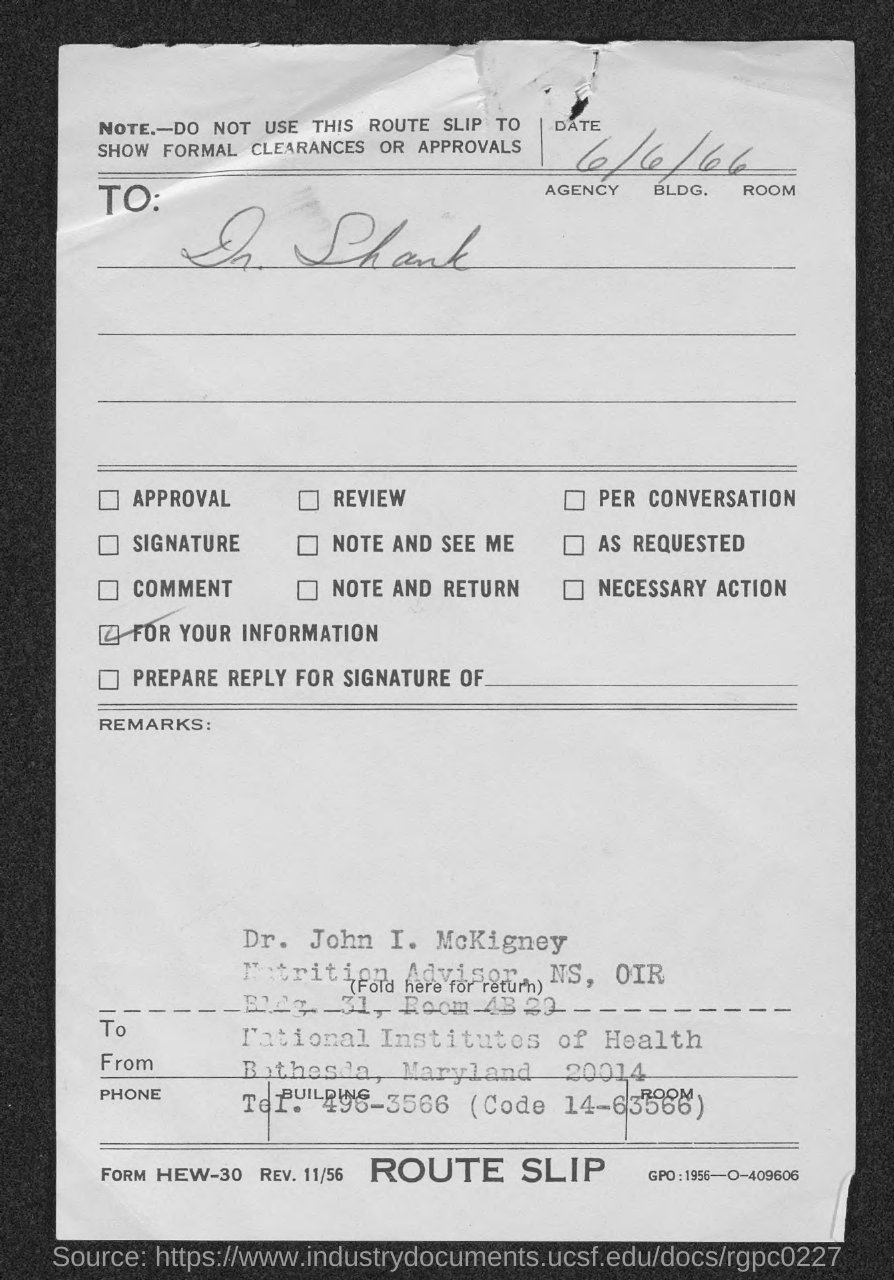What is the Date?
Your response must be concise. 6/6/66. To Whom is this letter addressed to?
Keep it short and to the point. Dr. Shank. 